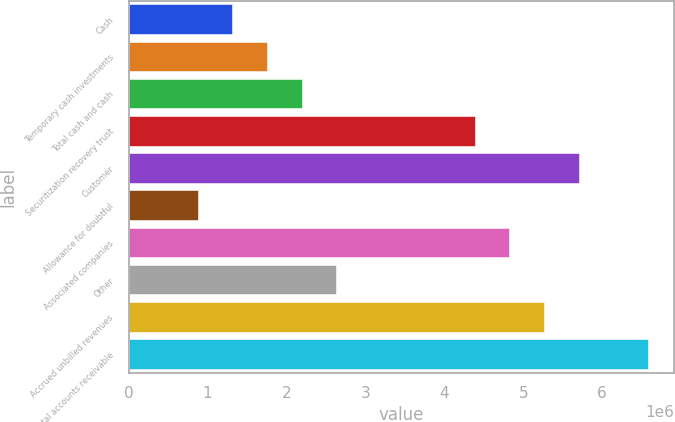Convert chart to OTSL. <chart><loc_0><loc_0><loc_500><loc_500><bar_chart><fcel>Cash<fcel>Temporary cash investments<fcel>Total cash and cash<fcel>Securitization recovery trust<fcel>Customer<fcel>Allowance for doubtful<fcel>Associated companies<fcel>Other<fcel>Accrued unbilled revenues<fcel>Total accounts receivable<nl><fcel>1.31585e+06<fcel>1.75434e+06<fcel>2.19284e+06<fcel>4.3853e+06<fcel>5.70077e+06<fcel>877360<fcel>4.82379e+06<fcel>2.63133e+06<fcel>5.26228e+06<fcel>6.57776e+06<nl></chart> 